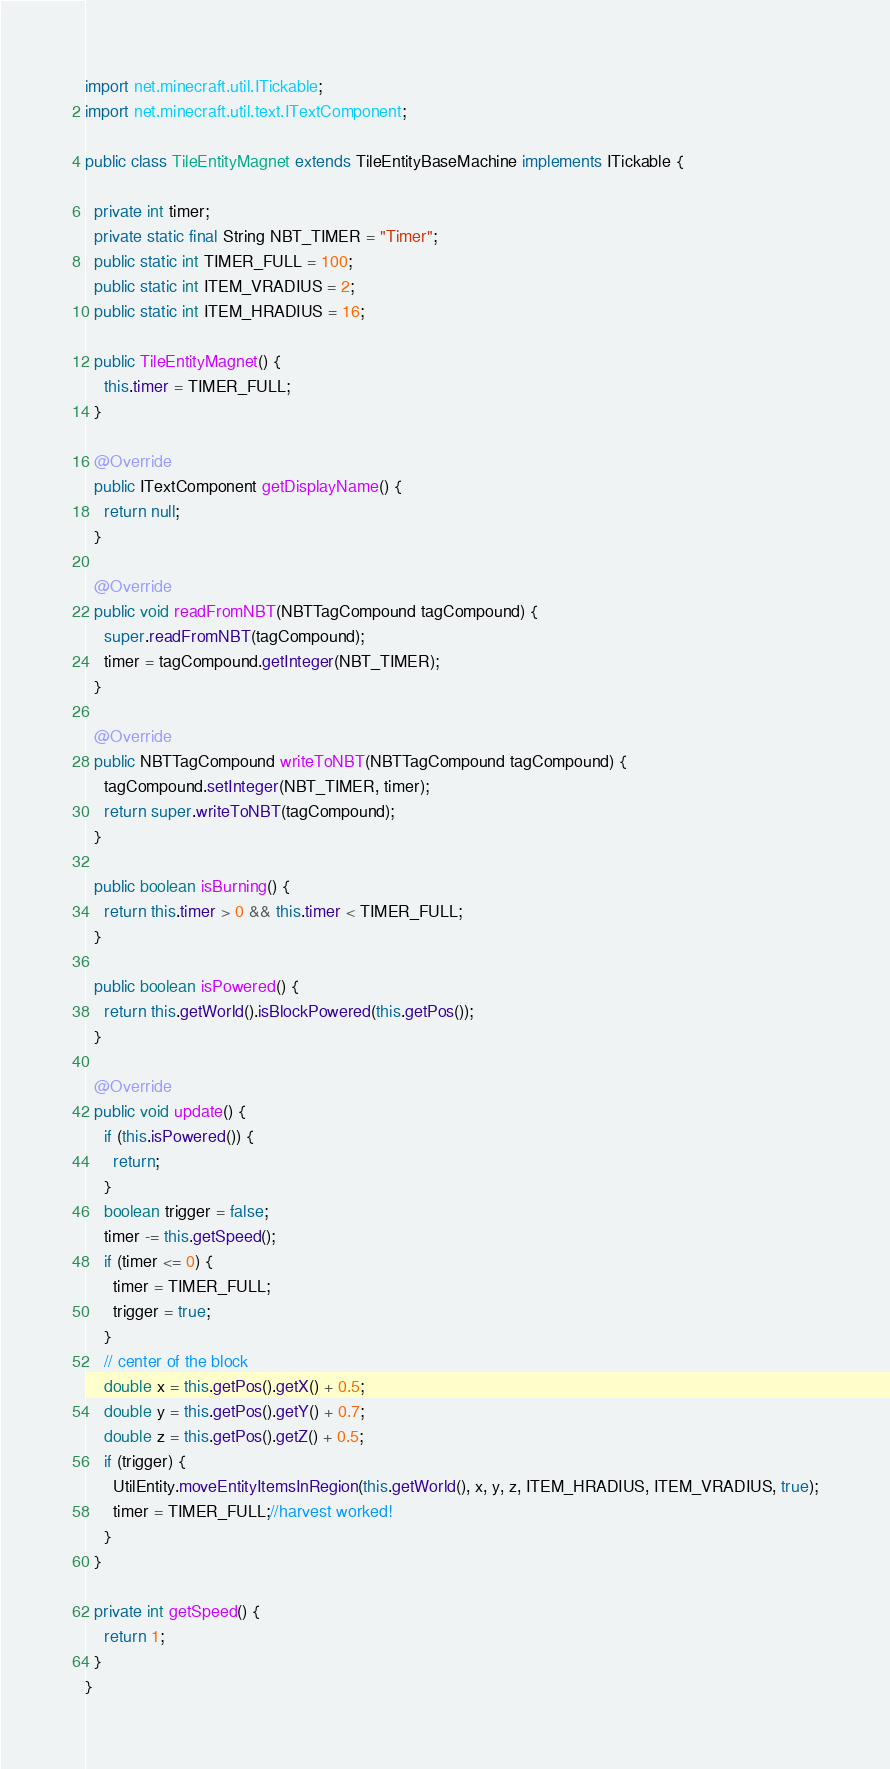Convert code to text. <code><loc_0><loc_0><loc_500><loc_500><_Java_>import net.minecraft.util.ITickable;
import net.minecraft.util.text.ITextComponent;

public class TileEntityMagnet extends TileEntityBaseMachine implements ITickable {

  private int timer;
  private static final String NBT_TIMER = "Timer";
  public static int TIMER_FULL = 100;
  public static int ITEM_VRADIUS = 2;
  public static int ITEM_HRADIUS = 16;

  public TileEntityMagnet() {
    this.timer = TIMER_FULL;
  }

  @Override
  public ITextComponent getDisplayName() {
    return null;
  }

  @Override
  public void readFromNBT(NBTTagCompound tagCompound) {
    super.readFromNBT(tagCompound);
    timer = tagCompound.getInteger(NBT_TIMER);
  }

  @Override
  public NBTTagCompound writeToNBT(NBTTagCompound tagCompound) {
    tagCompound.setInteger(NBT_TIMER, timer);
    return super.writeToNBT(tagCompound);
  }

  public boolean isBurning() {
    return this.timer > 0 && this.timer < TIMER_FULL;
  }

  public boolean isPowered() {
    return this.getWorld().isBlockPowered(this.getPos());
  }

  @Override
  public void update() {
    if (this.isPowered()) {
      return;
    }
    boolean trigger = false;
    timer -= this.getSpeed();
    if (timer <= 0) {
      timer = TIMER_FULL;
      trigger = true;
    }
    // center of the block
    double x = this.getPos().getX() + 0.5;
    double y = this.getPos().getY() + 0.7;
    double z = this.getPos().getZ() + 0.5;
    if (trigger) {
      UtilEntity.moveEntityItemsInRegion(this.getWorld(), x, y, z, ITEM_HRADIUS, ITEM_VRADIUS, true);
      timer = TIMER_FULL;//harvest worked!
    }
  }

  private int getSpeed() {
    return 1;
  }
}
</code> 